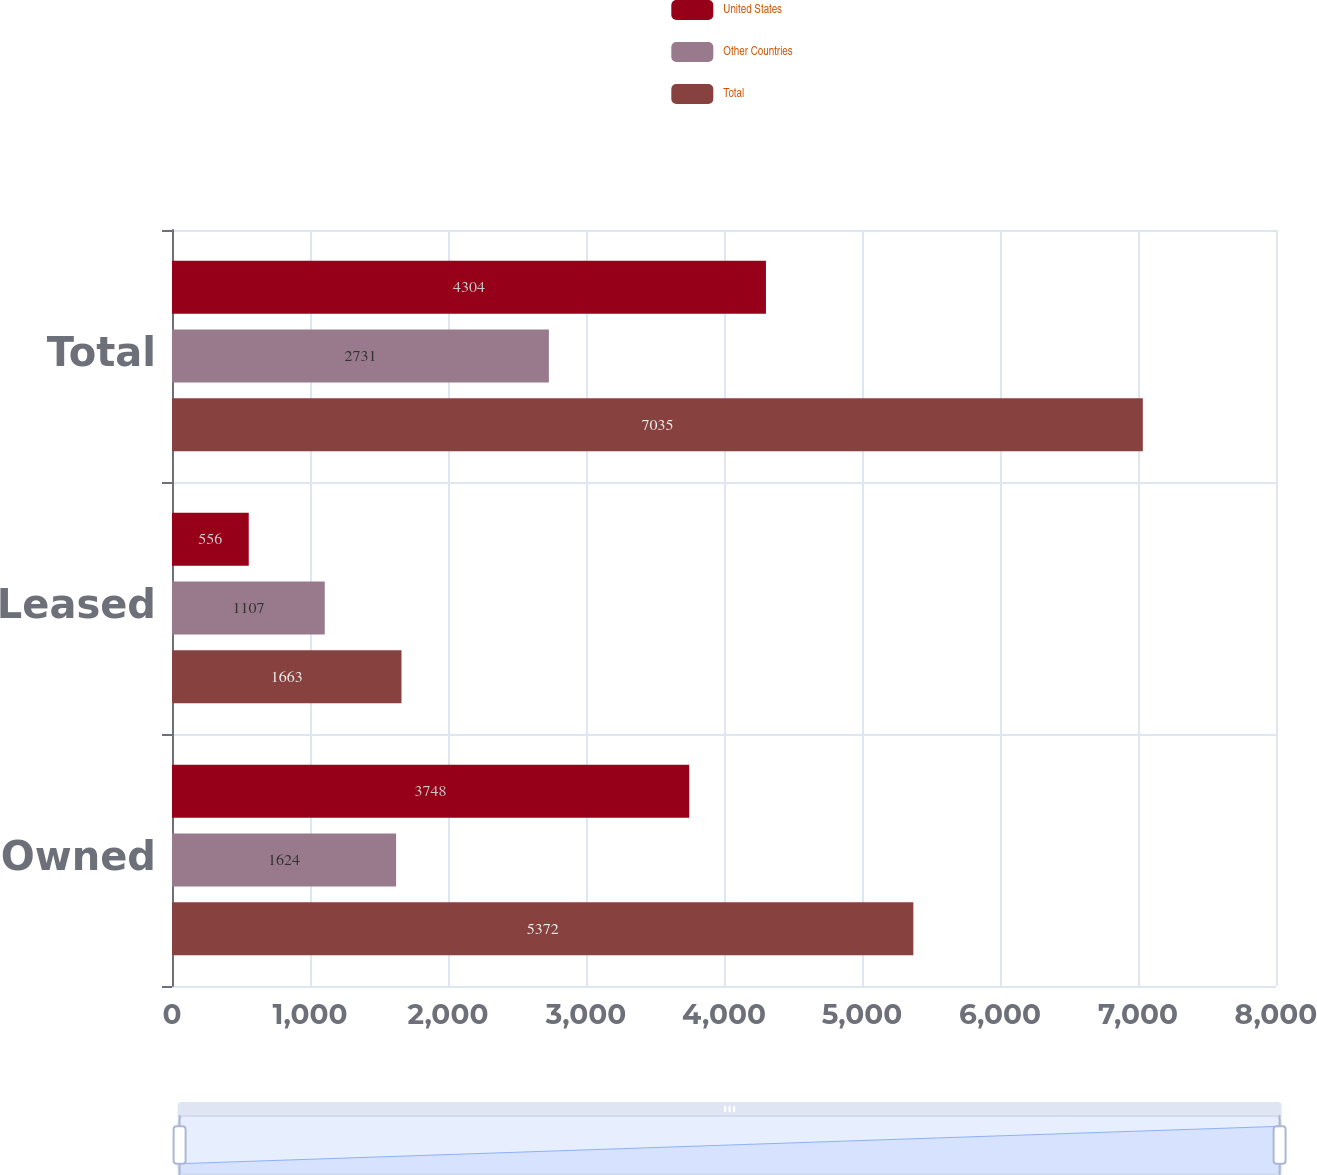<chart> <loc_0><loc_0><loc_500><loc_500><stacked_bar_chart><ecel><fcel>Owned<fcel>Leased<fcel>Total<nl><fcel>United States<fcel>3748<fcel>556<fcel>4304<nl><fcel>Other Countries<fcel>1624<fcel>1107<fcel>2731<nl><fcel>Total<fcel>5372<fcel>1663<fcel>7035<nl></chart> 